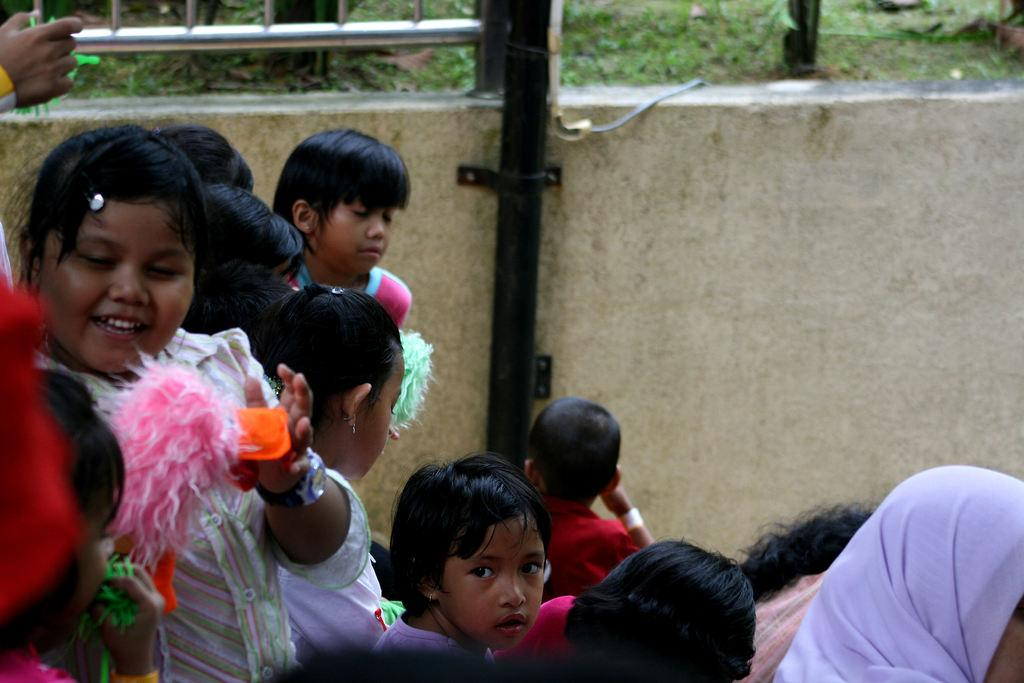Who is present in the image? There are kids in the image. What can be seen in the background of the image? There is a wall, a rod, and a fence in the background of the image. What type of mint is growing on the fence in the image? There is no mint growing on the fence in the image; the fence is a separate element in the background. 